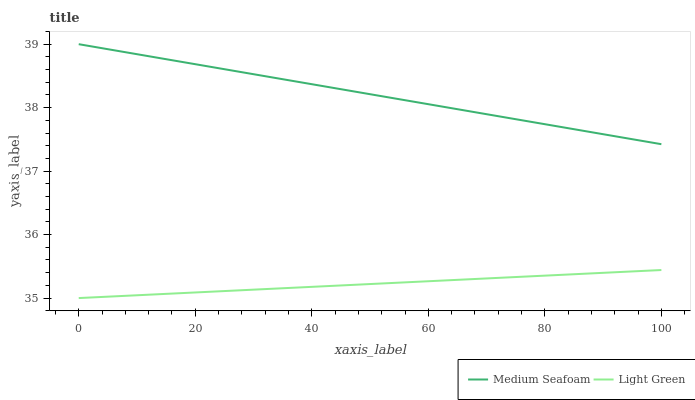Does Light Green have the minimum area under the curve?
Answer yes or no. Yes. Does Medium Seafoam have the maximum area under the curve?
Answer yes or no. Yes. Does Light Green have the maximum area under the curve?
Answer yes or no. No. Is Medium Seafoam the smoothest?
Answer yes or no. Yes. Is Light Green the roughest?
Answer yes or no. Yes. Is Light Green the smoothest?
Answer yes or no. No. Does Light Green have the lowest value?
Answer yes or no. Yes. Does Medium Seafoam have the highest value?
Answer yes or no. Yes. Does Light Green have the highest value?
Answer yes or no. No. Is Light Green less than Medium Seafoam?
Answer yes or no. Yes. Is Medium Seafoam greater than Light Green?
Answer yes or no. Yes. Does Light Green intersect Medium Seafoam?
Answer yes or no. No. 